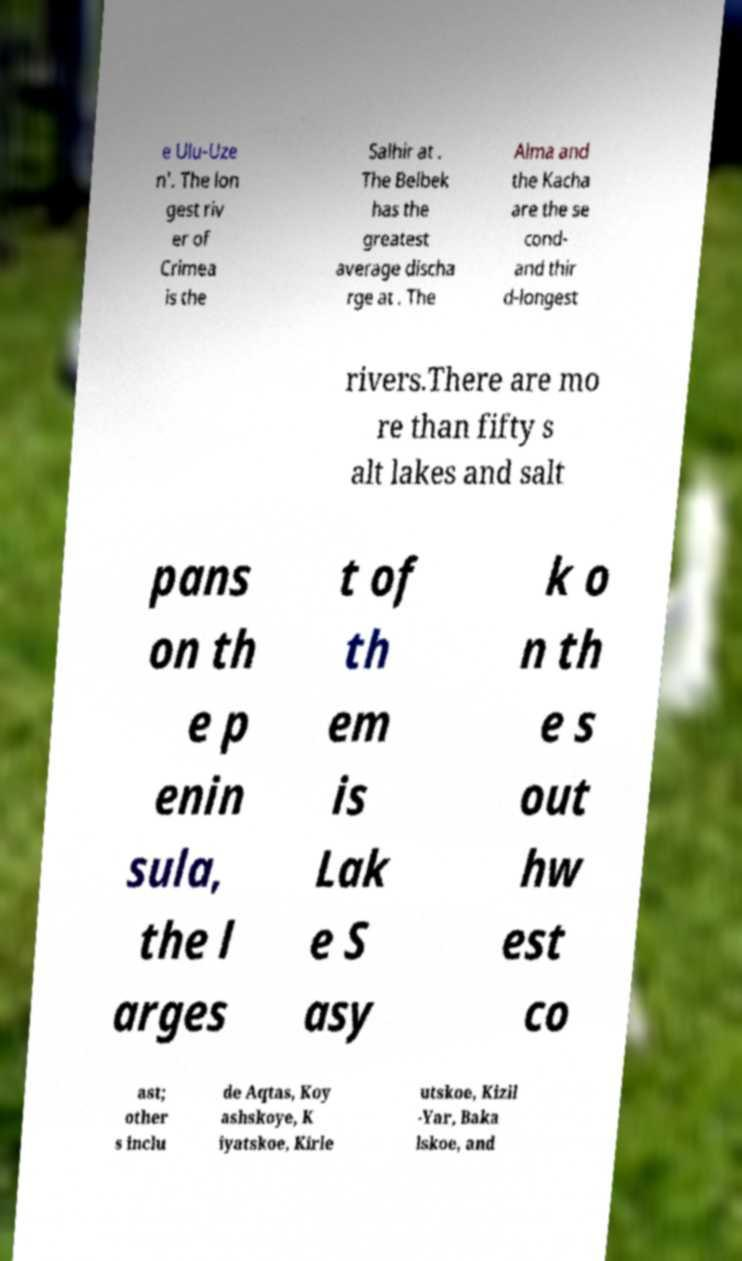Can you read and provide the text displayed in the image?This photo seems to have some interesting text. Can you extract and type it out for me? e Ulu-Uze n'. The lon gest riv er of Crimea is the Salhir at . The Belbek has the greatest average discha rge at . The Alma and the Kacha are the se cond- and thir d-longest rivers.There are mo re than fifty s alt lakes and salt pans on th e p enin sula, the l arges t of th em is Lak e S asy k o n th e s out hw est co ast; other s inclu de Aqtas, Koy ashskoye, K iyatskoe, Kirle utskoe, Kizil -Yar, Baka lskoe, and 